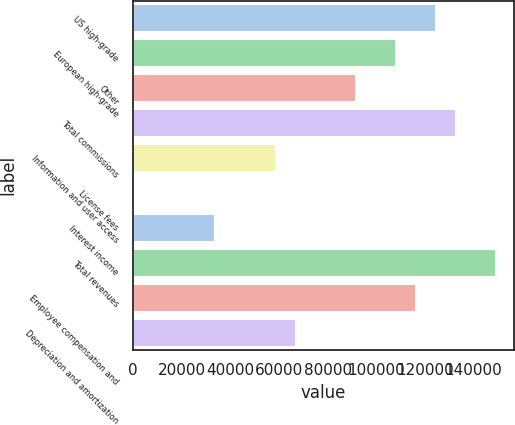<chart> <loc_0><loc_0><loc_500><loc_500><bar_chart><fcel>US high-grade<fcel>European high-grade<fcel>Other<fcel>Total commissions<fcel>Information and user access<fcel>License fees<fcel>Interest income<fcel>Total revenues<fcel>Employee compensation and<fcel>Depreciation and amortization<nl><fcel>124541<fcel>108051<fcel>91561<fcel>132786<fcel>58581<fcel>866<fcel>33846<fcel>149276<fcel>116296<fcel>66826<nl></chart> 